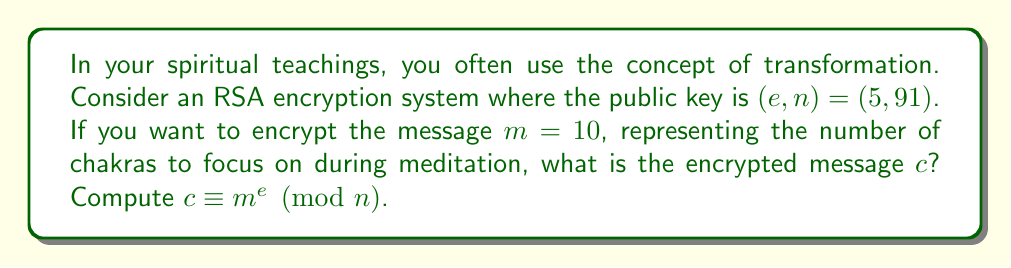Teach me how to tackle this problem. To encrypt the message using RSA, we need to compute the modular exponentiation:

$c \equiv m^e \pmod{n}$

Given:
$m = 10$ (the message)
$e = 5$ (the public exponent)
$n = 91$ (the modulus)

Let's calculate step by step:

1) $c \equiv 10^5 \pmod{91}$

2) To efficiently compute this, we can use the square-and-multiply method:

   $10^1 \equiv 10 \pmod{91}$
   $10^2 \equiv 100 \equiv 9 \pmod{91}$
   $10^4 \equiv 9^2 \equiv 81 \pmod{91}$

3) Now, $10^5 = 10^4 \cdot 10^1$, so:

   $10^5 \equiv 81 \cdot 10 \pmod{91}$

4) $81 \cdot 10 = 810$

5) $810 \div 91 = 8$ remainder $82$

Therefore, $c \equiv 82 \pmod{91}$
Answer: $82$ 